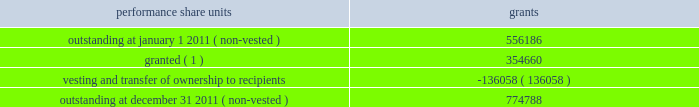During the year ended december 31 , 2011 , we granted 354660 performance share units having a fair value based on our grant date closing stock price of $ 28.79 .
These units are payable in stock and are subject to certain financial performance criteria .
The fair value of these performance share unit awards is based on the grant date closing stock price of each respective award grant and will apply to the number of units ultimately awarded .
The number of shares ultimately issued for each award will be based on our financial performance as compared to peer group companies over the performance period and can range from zero to 200% ( 200 % ) .
As of december 31 , 2011 , estimated share payouts for outstanding non-vested performance share unit awards ranged from 150% ( 150 % ) to 195% ( 195 % ) .
For the legacy frontier performance share units assumed at july 1 , 2011 , performance is based on market performance criteria , which is calculated as the total shareholder return achieved by hollyfrontier stockholders compared with the average shareholder return achieved by an equally-weighted peer group of independent refining companies over a three-year period .
These share unit awards are payable in stock based on share price performance relative to the defined peer group and can range from zero to 125% ( 125 % ) of the initial target award .
These performance share units were valued at july 1 , 2011 using a monte carlo valuation model , which simulates future stock price movements using key inputs including grant date and measurement date stock prices , expected stock price performance , expected rate of return and volatility of our stock price relative to the peer group over the three-year performance period .
The fair value of these performance share units at july 1 , 2011 was $ 8.6 million .
Of this amount , $ 7.3 million relates to post-merger services and will be recognized ratably over the remaining service period through 2013 .
A summary of performance share unit activity and changes during the year ended december 31 , 2011 is presented below: .
( 1 ) includes 225116 non-vested performance share grants under the legacy frontier plan that were outstanding and retained by hollyfrontier at july 1 , 2011 .
For the year ended december 31 , 2011 we issued 178148 shares of our common stock having a fair value of $ 2.6 million related to vested performance share units .
Based on the weighted average grant date fair value of $ 20.71 there was $ 11.7 million of total unrecognized compensation cost related to non-vested performance share units .
That cost is expected to be recognized over a weighted-average period of 1.1 years .
Note 7 : cash and cash equivalents and investments in marketable securities our investment portfolio at december 31 , 2011 consisted of cash , cash equivalents and investments in debt securities primarily issued by government and municipal entities .
We also hold 1000000 shares of connacher oil and gas limited common stock that was received as partial consideration upon the sale of our montana refinery in we invest in highly-rated marketable debt securities , primarily issued by government and municipal entities that have maturities at the date of purchase of greater than three months .
We also invest in other marketable debt securities with the maximum maturity or put date of any individual issue generally not greater than two years from the date of purchase .
All of these instruments , including investments in equity securities , are classified as available- for-sale .
As a result , they are reported at fair value using quoted market prices .
Interest income is recorded as earned .
Unrealized gains and losses , net of related income taxes , are reported as a component of accumulated other comprehensive income .
Upon sale , realized gains and losses on the sale of marketable securities are computed based on the specific identification of the underlying cost of the securities sold and the unrealized gains and losses previously reported in other comprehensive income are reclassified to current earnings. .
What percentage of july 2011 performance shares does not relate to post-merger services? 
Computations: ((8.6 - 7.3) / 8.6)
Answer: 0.15116. 